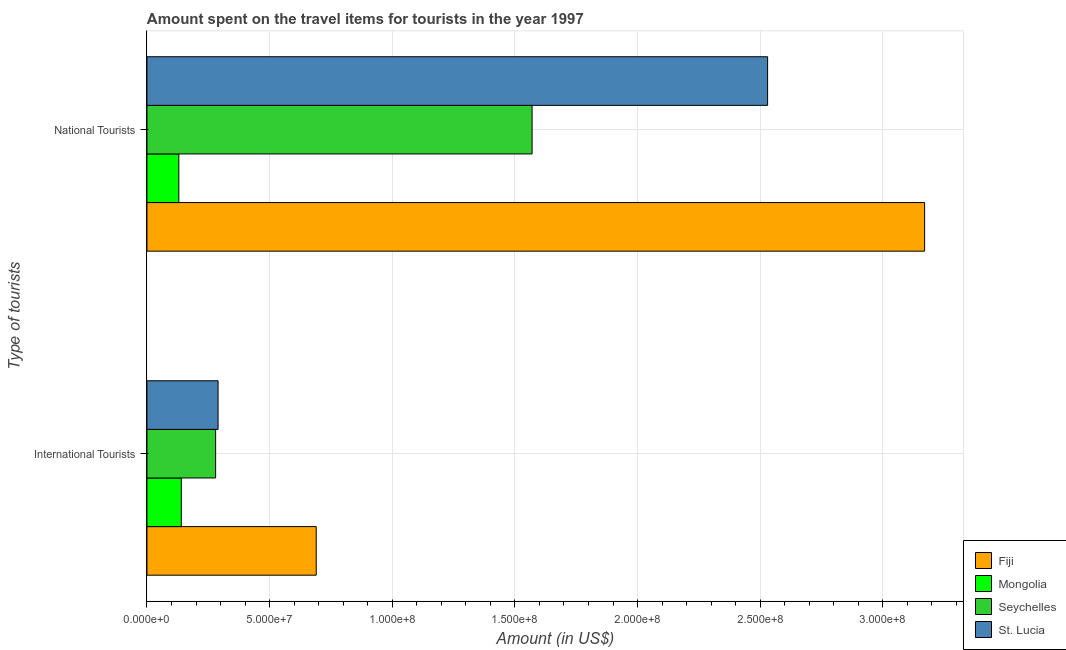How many different coloured bars are there?
Provide a short and direct response. 4. How many groups of bars are there?
Your answer should be very brief. 2. Are the number of bars per tick equal to the number of legend labels?
Your response must be concise. Yes. Are the number of bars on each tick of the Y-axis equal?
Offer a terse response. Yes. How many bars are there on the 1st tick from the bottom?
Offer a terse response. 4. What is the label of the 1st group of bars from the top?
Your answer should be very brief. National Tourists. What is the amount spent on travel items of international tourists in Fiji?
Provide a succinct answer. 6.90e+07. Across all countries, what is the maximum amount spent on travel items of national tourists?
Give a very brief answer. 3.17e+08. Across all countries, what is the minimum amount spent on travel items of international tourists?
Your answer should be compact. 1.40e+07. In which country was the amount spent on travel items of international tourists maximum?
Provide a succinct answer. Fiji. In which country was the amount spent on travel items of international tourists minimum?
Your answer should be very brief. Mongolia. What is the total amount spent on travel items of national tourists in the graph?
Give a very brief answer. 7.40e+08. What is the difference between the amount spent on travel items of international tourists in Fiji and that in St. Lucia?
Provide a short and direct response. 4.00e+07. What is the difference between the amount spent on travel items of national tourists in Fiji and the amount spent on travel items of international tourists in St. Lucia?
Give a very brief answer. 2.88e+08. What is the average amount spent on travel items of international tourists per country?
Provide a succinct answer. 3.50e+07. What is the difference between the amount spent on travel items of international tourists and amount spent on travel items of national tourists in Seychelles?
Your response must be concise. -1.29e+08. In how many countries, is the amount spent on travel items of international tourists greater than 30000000 US$?
Offer a terse response. 1. What is the ratio of the amount spent on travel items of international tourists in St. Lucia to that in Fiji?
Make the answer very short. 0.42. Is the amount spent on travel items of national tourists in St. Lucia less than that in Fiji?
Your answer should be compact. Yes. What does the 1st bar from the top in National Tourists represents?
Provide a succinct answer. St. Lucia. What does the 4th bar from the bottom in International Tourists represents?
Your answer should be compact. St. Lucia. How many bars are there?
Make the answer very short. 8. How many countries are there in the graph?
Ensure brevity in your answer.  4. Are the values on the major ticks of X-axis written in scientific E-notation?
Provide a short and direct response. Yes. How many legend labels are there?
Your answer should be compact. 4. How are the legend labels stacked?
Make the answer very short. Vertical. What is the title of the graph?
Provide a succinct answer. Amount spent on the travel items for tourists in the year 1997. What is the label or title of the Y-axis?
Your answer should be very brief. Type of tourists. What is the Amount (in US$) of Fiji in International Tourists?
Your answer should be compact. 6.90e+07. What is the Amount (in US$) of Mongolia in International Tourists?
Offer a terse response. 1.40e+07. What is the Amount (in US$) in Seychelles in International Tourists?
Provide a short and direct response. 2.80e+07. What is the Amount (in US$) in St. Lucia in International Tourists?
Ensure brevity in your answer.  2.90e+07. What is the Amount (in US$) in Fiji in National Tourists?
Make the answer very short. 3.17e+08. What is the Amount (in US$) in Mongolia in National Tourists?
Your answer should be very brief. 1.30e+07. What is the Amount (in US$) in Seychelles in National Tourists?
Keep it short and to the point. 1.57e+08. What is the Amount (in US$) of St. Lucia in National Tourists?
Offer a terse response. 2.53e+08. Across all Type of tourists, what is the maximum Amount (in US$) of Fiji?
Make the answer very short. 3.17e+08. Across all Type of tourists, what is the maximum Amount (in US$) of Mongolia?
Keep it short and to the point. 1.40e+07. Across all Type of tourists, what is the maximum Amount (in US$) of Seychelles?
Offer a terse response. 1.57e+08. Across all Type of tourists, what is the maximum Amount (in US$) in St. Lucia?
Provide a short and direct response. 2.53e+08. Across all Type of tourists, what is the minimum Amount (in US$) of Fiji?
Give a very brief answer. 6.90e+07. Across all Type of tourists, what is the minimum Amount (in US$) of Mongolia?
Your answer should be very brief. 1.30e+07. Across all Type of tourists, what is the minimum Amount (in US$) in Seychelles?
Ensure brevity in your answer.  2.80e+07. Across all Type of tourists, what is the minimum Amount (in US$) of St. Lucia?
Your answer should be very brief. 2.90e+07. What is the total Amount (in US$) of Fiji in the graph?
Offer a terse response. 3.86e+08. What is the total Amount (in US$) of Mongolia in the graph?
Keep it short and to the point. 2.70e+07. What is the total Amount (in US$) in Seychelles in the graph?
Provide a succinct answer. 1.85e+08. What is the total Amount (in US$) of St. Lucia in the graph?
Provide a short and direct response. 2.82e+08. What is the difference between the Amount (in US$) of Fiji in International Tourists and that in National Tourists?
Provide a succinct answer. -2.48e+08. What is the difference between the Amount (in US$) of Mongolia in International Tourists and that in National Tourists?
Offer a terse response. 1.00e+06. What is the difference between the Amount (in US$) in Seychelles in International Tourists and that in National Tourists?
Your answer should be compact. -1.29e+08. What is the difference between the Amount (in US$) in St. Lucia in International Tourists and that in National Tourists?
Your answer should be very brief. -2.24e+08. What is the difference between the Amount (in US$) in Fiji in International Tourists and the Amount (in US$) in Mongolia in National Tourists?
Your answer should be very brief. 5.60e+07. What is the difference between the Amount (in US$) in Fiji in International Tourists and the Amount (in US$) in Seychelles in National Tourists?
Offer a very short reply. -8.80e+07. What is the difference between the Amount (in US$) of Fiji in International Tourists and the Amount (in US$) of St. Lucia in National Tourists?
Ensure brevity in your answer.  -1.84e+08. What is the difference between the Amount (in US$) in Mongolia in International Tourists and the Amount (in US$) in Seychelles in National Tourists?
Offer a very short reply. -1.43e+08. What is the difference between the Amount (in US$) in Mongolia in International Tourists and the Amount (in US$) in St. Lucia in National Tourists?
Keep it short and to the point. -2.39e+08. What is the difference between the Amount (in US$) of Seychelles in International Tourists and the Amount (in US$) of St. Lucia in National Tourists?
Provide a short and direct response. -2.25e+08. What is the average Amount (in US$) of Fiji per Type of tourists?
Offer a very short reply. 1.93e+08. What is the average Amount (in US$) of Mongolia per Type of tourists?
Give a very brief answer. 1.35e+07. What is the average Amount (in US$) in Seychelles per Type of tourists?
Your answer should be compact. 9.25e+07. What is the average Amount (in US$) in St. Lucia per Type of tourists?
Your response must be concise. 1.41e+08. What is the difference between the Amount (in US$) in Fiji and Amount (in US$) in Mongolia in International Tourists?
Ensure brevity in your answer.  5.50e+07. What is the difference between the Amount (in US$) in Fiji and Amount (in US$) in Seychelles in International Tourists?
Your answer should be compact. 4.10e+07. What is the difference between the Amount (in US$) of Fiji and Amount (in US$) of St. Lucia in International Tourists?
Offer a very short reply. 4.00e+07. What is the difference between the Amount (in US$) of Mongolia and Amount (in US$) of Seychelles in International Tourists?
Provide a succinct answer. -1.40e+07. What is the difference between the Amount (in US$) of Mongolia and Amount (in US$) of St. Lucia in International Tourists?
Offer a terse response. -1.50e+07. What is the difference between the Amount (in US$) of Seychelles and Amount (in US$) of St. Lucia in International Tourists?
Provide a succinct answer. -1.00e+06. What is the difference between the Amount (in US$) of Fiji and Amount (in US$) of Mongolia in National Tourists?
Provide a succinct answer. 3.04e+08. What is the difference between the Amount (in US$) in Fiji and Amount (in US$) in Seychelles in National Tourists?
Keep it short and to the point. 1.60e+08. What is the difference between the Amount (in US$) in Fiji and Amount (in US$) in St. Lucia in National Tourists?
Your response must be concise. 6.40e+07. What is the difference between the Amount (in US$) of Mongolia and Amount (in US$) of Seychelles in National Tourists?
Provide a short and direct response. -1.44e+08. What is the difference between the Amount (in US$) in Mongolia and Amount (in US$) in St. Lucia in National Tourists?
Your answer should be very brief. -2.40e+08. What is the difference between the Amount (in US$) of Seychelles and Amount (in US$) of St. Lucia in National Tourists?
Offer a terse response. -9.60e+07. What is the ratio of the Amount (in US$) in Fiji in International Tourists to that in National Tourists?
Make the answer very short. 0.22. What is the ratio of the Amount (in US$) of Seychelles in International Tourists to that in National Tourists?
Offer a very short reply. 0.18. What is the ratio of the Amount (in US$) in St. Lucia in International Tourists to that in National Tourists?
Keep it short and to the point. 0.11. What is the difference between the highest and the second highest Amount (in US$) in Fiji?
Offer a very short reply. 2.48e+08. What is the difference between the highest and the second highest Amount (in US$) of Mongolia?
Keep it short and to the point. 1.00e+06. What is the difference between the highest and the second highest Amount (in US$) in Seychelles?
Offer a very short reply. 1.29e+08. What is the difference between the highest and the second highest Amount (in US$) in St. Lucia?
Ensure brevity in your answer.  2.24e+08. What is the difference between the highest and the lowest Amount (in US$) in Fiji?
Offer a terse response. 2.48e+08. What is the difference between the highest and the lowest Amount (in US$) in Mongolia?
Your answer should be very brief. 1.00e+06. What is the difference between the highest and the lowest Amount (in US$) in Seychelles?
Your response must be concise. 1.29e+08. What is the difference between the highest and the lowest Amount (in US$) of St. Lucia?
Your response must be concise. 2.24e+08. 